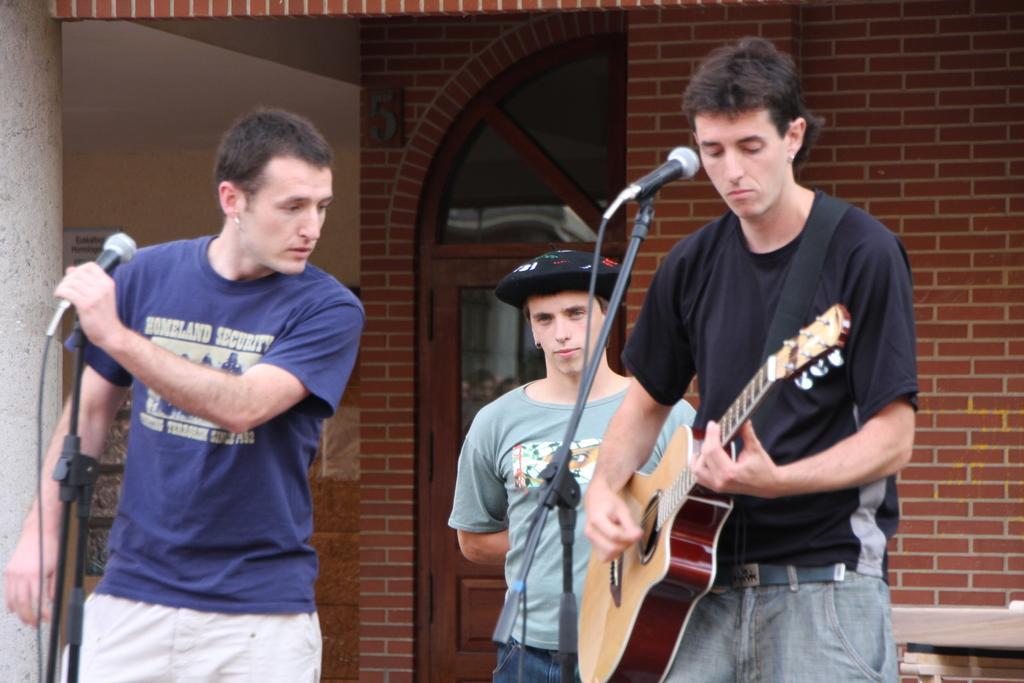Could you give a brief overview of what you see in this image? In this image i can see 3 persons standing, one of them is holding a guitar in his hand and there is a microphone in front of him and the person in the left side of the image is holding a microphone in his hand. In the background i can see a building made of bricks and a door. 